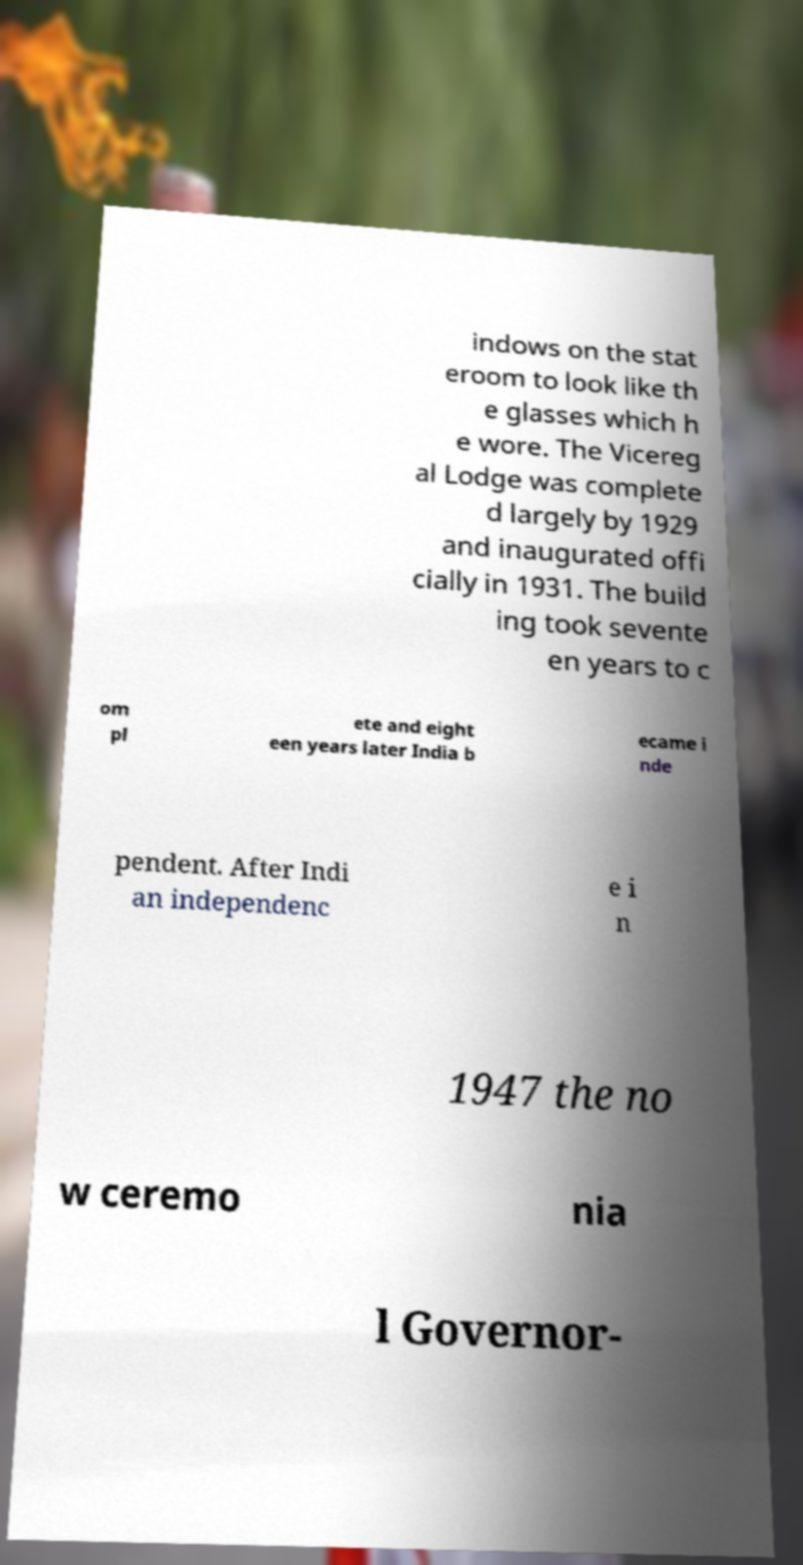Could you extract and type out the text from this image? indows on the stat eroom to look like th e glasses which h e wore. The Vicereg al Lodge was complete d largely by 1929 and inaugurated offi cially in 1931. The build ing took sevente en years to c om pl ete and eight een years later India b ecame i nde pendent. After Indi an independenc e i n 1947 the no w ceremo nia l Governor- 